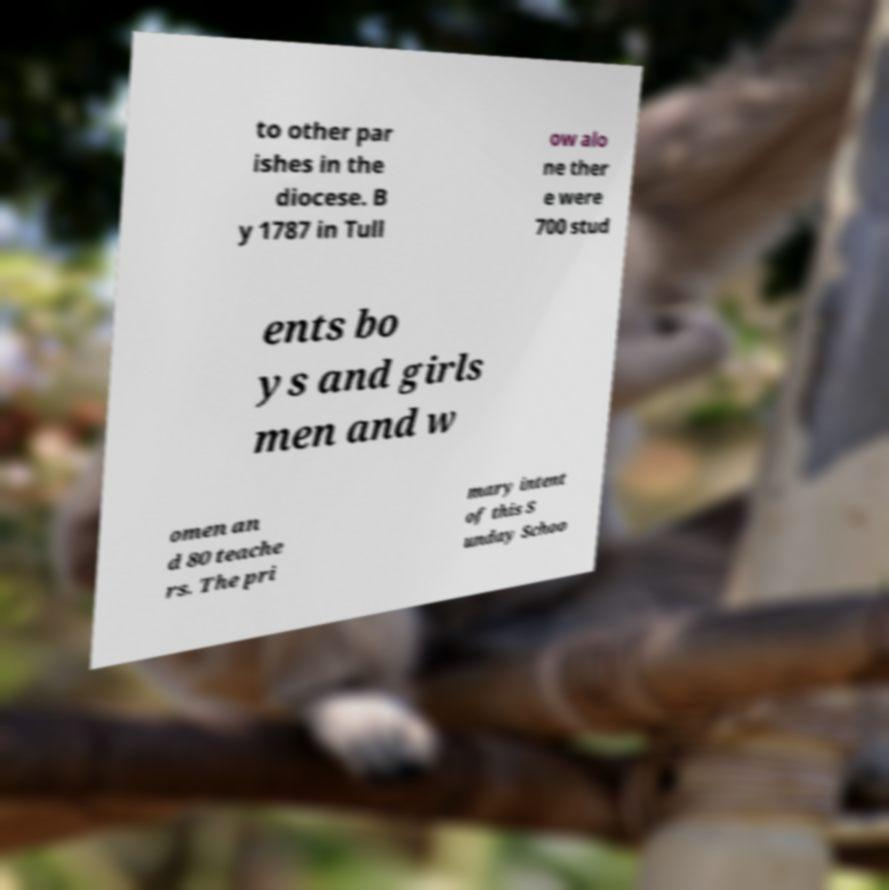Could you assist in decoding the text presented in this image and type it out clearly? to other par ishes in the diocese. B y 1787 in Tull ow alo ne ther e were 700 stud ents bo ys and girls men and w omen an d 80 teache rs. The pri mary intent of this S unday Schoo 